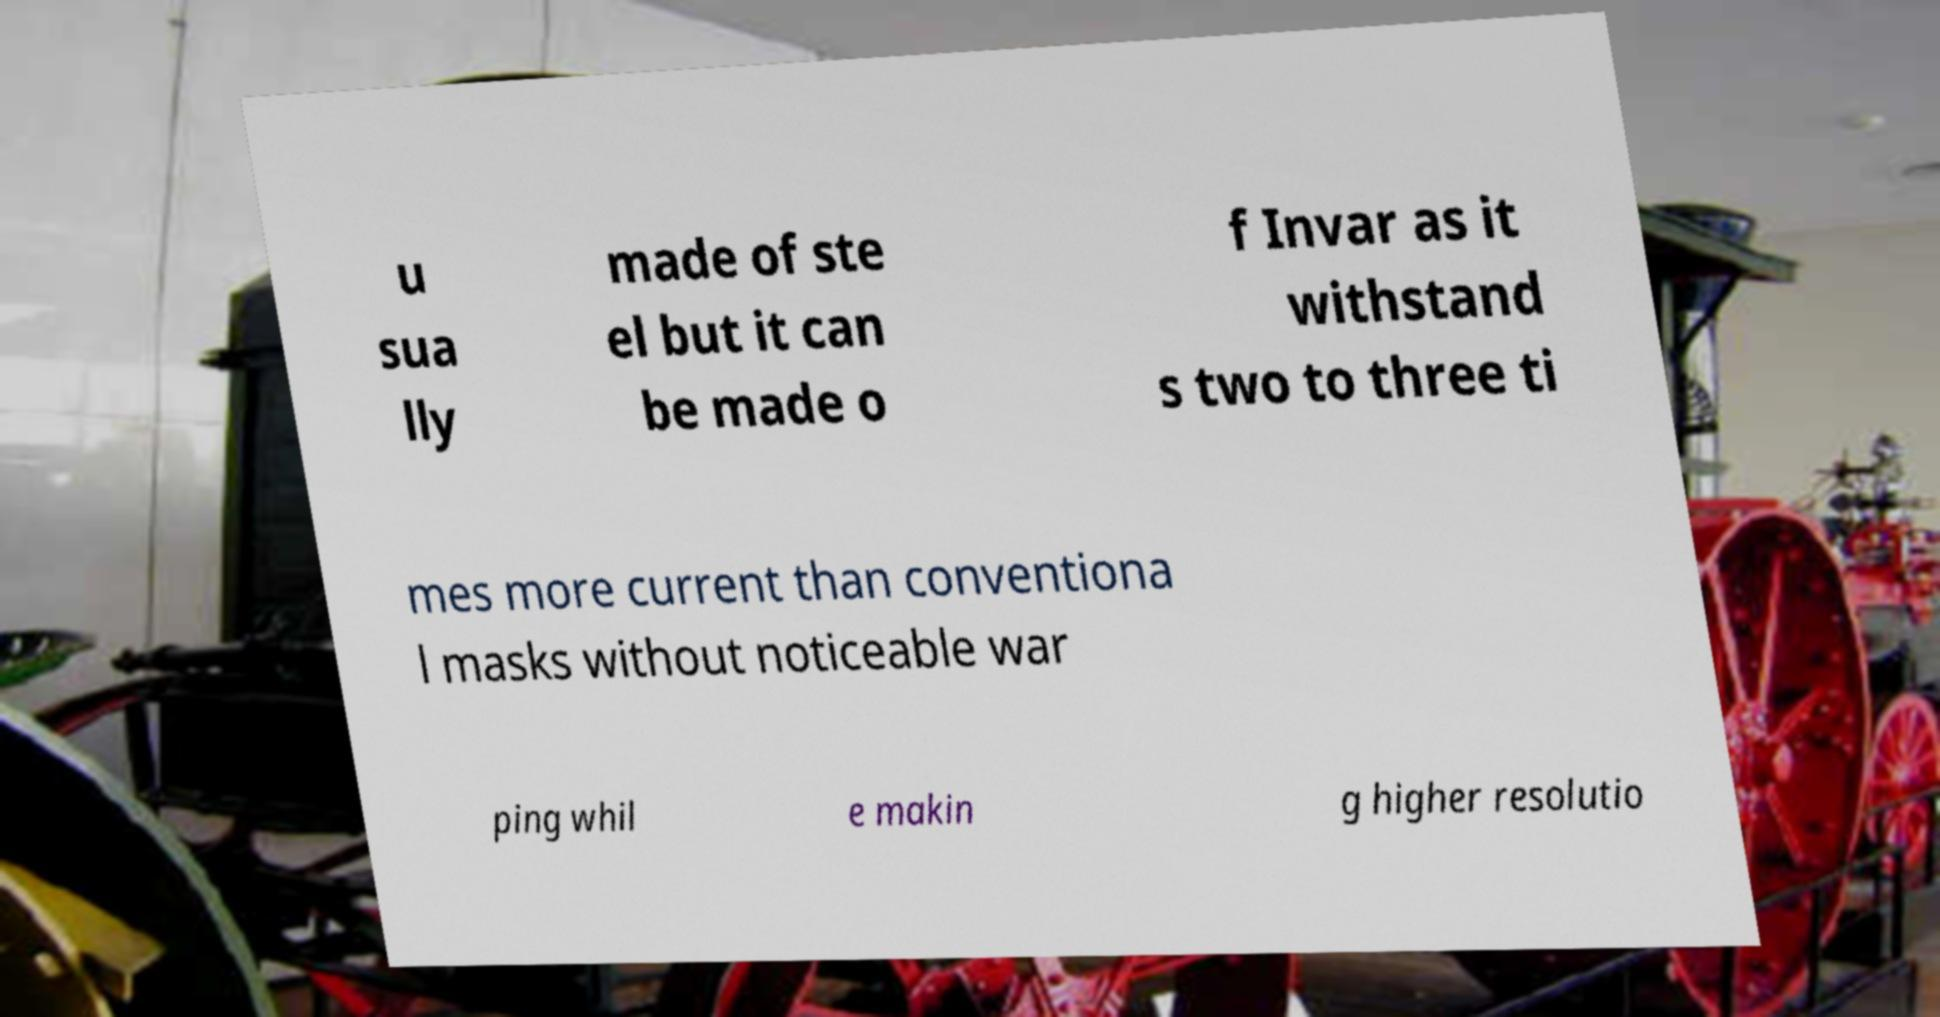For documentation purposes, I need the text within this image transcribed. Could you provide that? u sua lly made of ste el but it can be made o f Invar as it withstand s two to three ti mes more current than conventiona l masks without noticeable war ping whil e makin g higher resolutio 